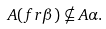Convert formula to latex. <formula><loc_0><loc_0><loc_500><loc_500>A ( f r \beta ) \nsubseteq A \alpha .</formula> 